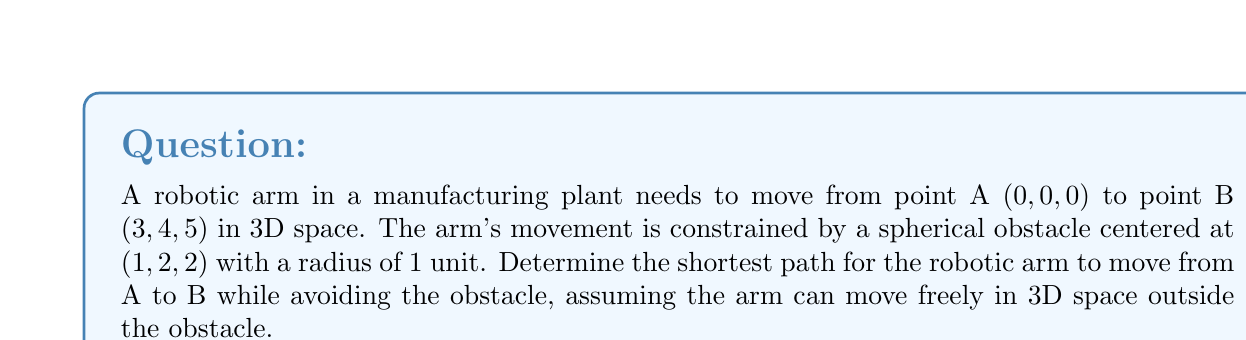Provide a solution to this math problem. To solve this problem, we'll use concepts from differential geometry and optimization:

1) The shortest path between two points in 3D space is typically a straight line. However, the presence of the obstacle complicates this.

2) The optimal path will be the shortest curve that goes around the surface of the obstacle. This curve is known as a geodesic on the sphere.

3) To find this path, we can use the method of Lagrange multipliers:

   a) First, parameterize the sphere: 
      $$x = 1 + \sin\theta\cos\phi$$
      $$y = 2 + \sin\theta\sin\phi$$
      $$z = 2 + \cos\theta$$

   b) The length of the curve on the sphere is given by:
      $$L = \int_0^1 \sqrt{(\frac{dx}{dt})^2 + (\frac{dy}{dt})^2 + (\frac{dz}{dt})^2} dt$$

   c) Minimize this length subject to the constraint that the curve lies on the sphere:
      $$(x-1)^2 + (y-2)^2 + (z-2)^2 = 1$$

4) Solving this optimization problem leads to a system of differential equations. The solution to these equations gives us the geodesic.

5) The complete path consists of:
   - A straight line from A to the point where the path touches the sphere
   - The geodesic arc on the sphere
   - A straight line from the point where the path leaves the sphere to B

6) The exact solution requires numerical methods to solve the differential equations.

7) An approximation of the path length can be calculated as follows:
   - Length of straight line from A to sphere surface: $\approx 2.12$ units
   - Length of great circle arc on sphere: $\approx 1.57$ units (approximated as a quarter circle)
   - Length of straight line from sphere surface to B: $\approx 2.12$ units

8) Total approximate path length: $2.12 + 1.57 + 2.12 = 5.81$ units
Answer: The optimal path is approximately 5.81 units long, consisting of two straight line segments and a geodesic arc on the sphere. 